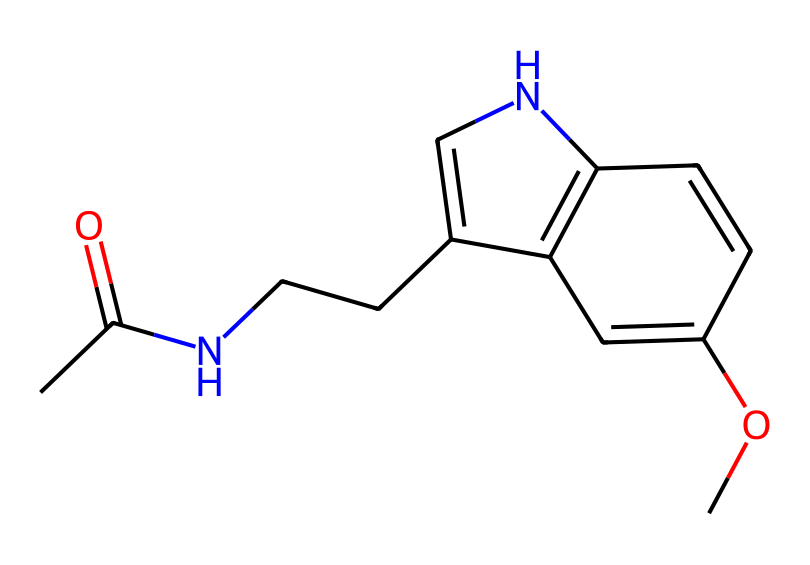What is the main functional group in melatonin? The chemical structure contains an amide functional group characterized by the presence of a carbonyl (C=O) adjacent to a nitrogen atom (N). This indicates the presence of an amide group connected to the rest of the molecule.
Answer: amide How many rings are present in the molecular structure? By inspecting the structure, there are two distinct cyclic components observable in the chemical diagram, confirming the presence of two rings in the structure.
Answer: two What is the total number of nitrogen atoms in melatonin? The representation shows only one nitrogen atom in the amide group and another nitrogen contributing to the ring structure, amounting to a total of two nitrogen atoms in the entire molecule.
Answer: two What type of compound does melatonin belong to? Melatonin serves as a medicinal compound primarily due to its sleep-regulating properties, which categorize it as a hormone involved in biological rhythms.
Answer: hormone Which part of the chemical structure aids in its solubility? The presence of the -OCH3 (methoxy) group in the structure enhances solubility in polar solvents, contributing to the molecule’s overall solubility characteristics.
Answer: methoxy group 